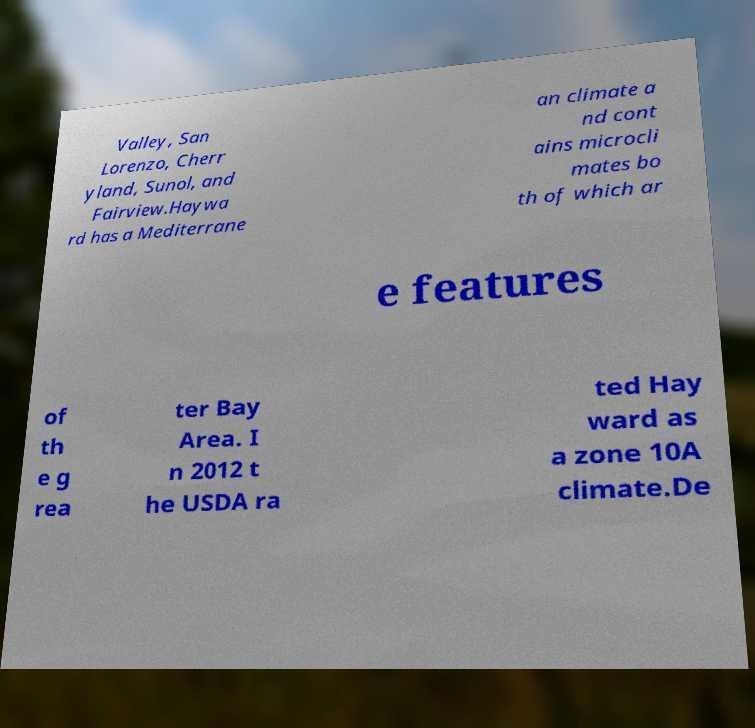There's text embedded in this image that I need extracted. Can you transcribe it verbatim? Valley, San Lorenzo, Cherr yland, Sunol, and Fairview.Haywa rd has a Mediterrane an climate a nd cont ains microcli mates bo th of which ar e features of th e g rea ter Bay Area. I n 2012 t he USDA ra ted Hay ward as a zone 10A climate.De 